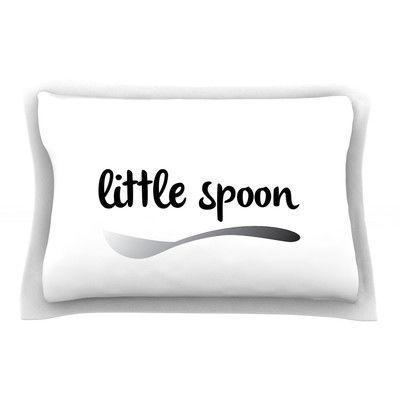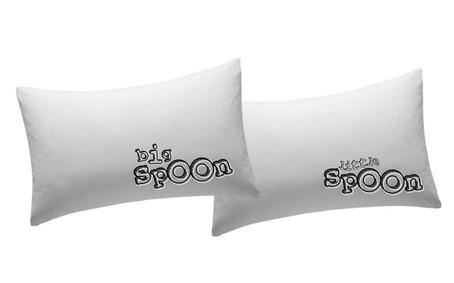The first image is the image on the left, the second image is the image on the right. Given the left and right images, does the statement "One image features a pillow design with a spoon pictured as well as black text, and the other image shows two rectangular white pillows with black text." hold true? Answer yes or no. Yes. The first image is the image on the left, the second image is the image on the right. Examine the images to the left and right. Is the description "The right image contains exactly two pillows." accurate? Answer yes or no. Yes. 